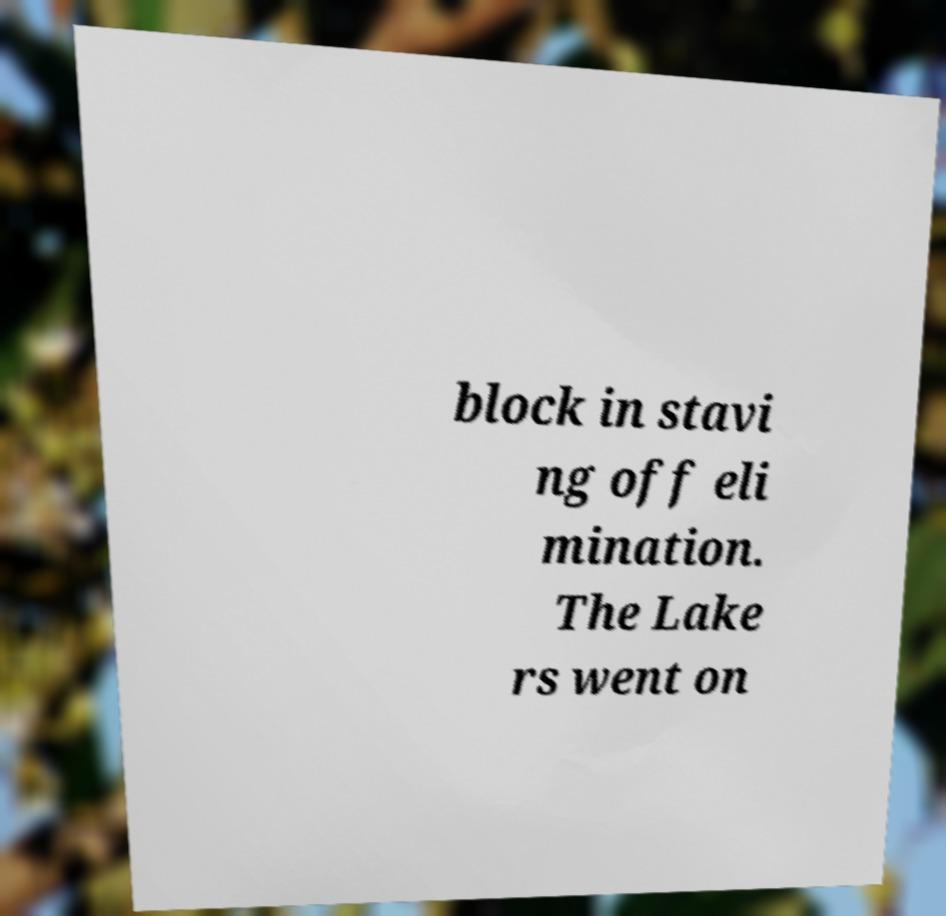I need the written content from this picture converted into text. Can you do that? block in stavi ng off eli mination. The Lake rs went on 